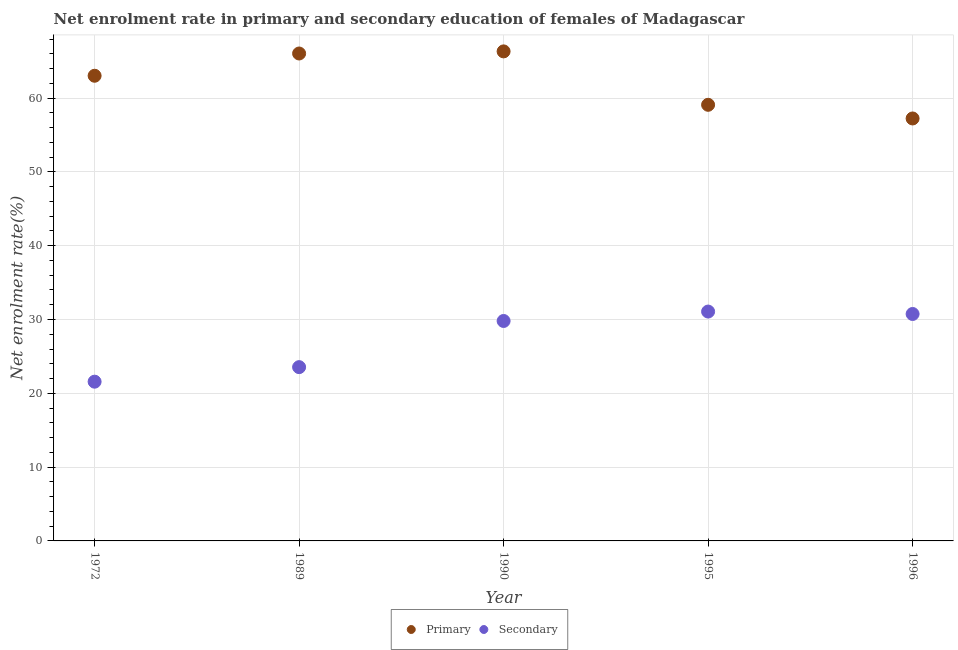Is the number of dotlines equal to the number of legend labels?
Ensure brevity in your answer.  Yes. What is the enrollment rate in primary education in 1972?
Your response must be concise. 63.02. Across all years, what is the maximum enrollment rate in primary education?
Offer a very short reply. 66.32. Across all years, what is the minimum enrollment rate in secondary education?
Your answer should be compact. 21.57. In which year was the enrollment rate in secondary education maximum?
Offer a terse response. 1995. In which year was the enrollment rate in secondary education minimum?
Make the answer very short. 1972. What is the total enrollment rate in primary education in the graph?
Offer a very short reply. 311.71. What is the difference between the enrollment rate in secondary education in 1990 and that in 1996?
Your answer should be compact. -0.95. What is the difference between the enrollment rate in secondary education in 1989 and the enrollment rate in primary education in 1990?
Provide a short and direct response. -42.78. What is the average enrollment rate in primary education per year?
Offer a very short reply. 62.34. In the year 1990, what is the difference between the enrollment rate in secondary education and enrollment rate in primary education?
Ensure brevity in your answer.  -36.52. What is the ratio of the enrollment rate in primary education in 1990 to that in 1996?
Provide a succinct answer. 1.16. Is the enrollment rate in secondary education in 1990 less than that in 1995?
Offer a terse response. Yes. What is the difference between the highest and the second highest enrollment rate in primary education?
Ensure brevity in your answer.  0.29. What is the difference between the highest and the lowest enrollment rate in primary education?
Offer a very short reply. 9.09. In how many years, is the enrollment rate in primary education greater than the average enrollment rate in primary education taken over all years?
Your response must be concise. 3. Does the enrollment rate in primary education monotonically increase over the years?
Provide a short and direct response. No. Is the enrollment rate in primary education strictly greater than the enrollment rate in secondary education over the years?
Your answer should be very brief. Yes. Is the enrollment rate in secondary education strictly less than the enrollment rate in primary education over the years?
Make the answer very short. Yes. How many dotlines are there?
Make the answer very short. 2. How many years are there in the graph?
Offer a terse response. 5. Does the graph contain grids?
Provide a short and direct response. Yes. Where does the legend appear in the graph?
Keep it short and to the point. Bottom center. How are the legend labels stacked?
Provide a short and direct response. Horizontal. What is the title of the graph?
Give a very brief answer. Net enrolment rate in primary and secondary education of females of Madagascar. Does "Working capital" appear as one of the legend labels in the graph?
Provide a succinct answer. No. What is the label or title of the X-axis?
Provide a succinct answer. Year. What is the label or title of the Y-axis?
Offer a terse response. Net enrolment rate(%). What is the Net enrolment rate(%) in Primary in 1972?
Ensure brevity in your answer.  63.02. What is the Net enrolment rate(%) of Secondary in 1972?
Ensure brevity in your answer.  21.57. What is the Net enrolment rate(%) in Primary in 1989?
Give a very brief answer. 66.04. What is the Net enrolment rate(%) in Secondary in 1989?
Your answer should be very brief. 23.55. What is the Net enrolment rate(%) of Primary in 1990?
Offer a terse response. 66.32. What is the Net enrolment rate(%) in Secondary in 1990?
Make the answer very short. 29.8. What is the Net enrolment rate(%) of Primary in 1995?
Provide a short and direct response. 59.09. What is the Net enrolment rate(%) in Secondary in 1995?
Ensure brevity in your answer.  31.08. What is the Net enrolment rate(%) in Primary in 1996?
Provide a short and direct response. 57.24. What is the Net enrolment rate(%) in Secondary in 1996?
Make the answer very short. 30.75. Across all years, what is the maximum Net enrolment rate(%) in Primary?
Keep it short and to the point. 66.32. Across all years, what is the maximum Net enrolment rate(%) of Secondary?
Make the answer very short. 31.08. Across all years, what is the minimum Net enrolment rate(%) of Primary?
Your answer should be very brief. 57.24. Across all years, what is the minimum Net enrolment rate(%) of Secondary?
Make the answer very short. 21.57. What is the total Net enrolment rate(%) in Primary in the graph?
Your answer should be very brief. 311.71. What is the total Net enrolment rate(%) in Secondary in the graph?
Provide a short and direct response. 136.74. What is the difference between the Net enrolment rate(%) in Primary in 1972 and that in 1989?
Ensure brevity in your answer.  -3.02. What is the difference between the Net enrolment rate(%) of Secondary in 1972 and that in 1989?
Provide a short and direct response. -1.97. What is the difference between the Net enrolment rate(%) of Primary in 1972 and that in 1990?
Offer a very short reply. -3.3. What is the difference between the Net enrolment rate(%) of Secondary in 1972 and that in 1990?
Keep it short and to the point. -8.22. What is the difference between the Net enrolment rate(%) in Primary in 1972 and that in 1995?
Keep it short and to the point. 3.94. What is the difference between the Net enrolment rate(%) of Secondary in 1972 and that in 1995?
Keep it short and to the point. -9.5. What is the difference between the Net enrolment rate(%) of Primary in 1972 and that in 1996?
Offer a very short reply. 5.79. What is the difference between the Net enrolment rate(%) in Secondary in 1972 and that in 1996?
Your response must be concise. -9.17. What is the difference between the Net enrolment rate(%) of Primary in 1989 and that in 1990?
Provide a succinct answer. -0.29. What is the difference between the Net enrolment rate(%) in Secondary in 1989 and that in 1990?
Make the answer very short. -6.25. What is the difference between the Net enrolment rate(%) of Primary in 1989 and that in 1995?
Ensure brevity in your answer.  6.95. What is the difference between the Net enrolment rate(%) in Secondary in 1989 and that in 1995?
Ensure brevity in your answer.  -7.53. What is the difference between the Net enrolment rate(%) in Primary in 1989 and that in 1996?
Keep it short and to the point. 8.8. What is the difference between the Net enrolment rate(%) of Secondary in 1989 and that in 1996?
Keep it short and to the point. -7.2. What is the difference between the Net enrolment rate(%) in Primary in 1990 and that in 1995?
Your response must be concise. 7.24. What is the difference between the Net enrolment rate(%) in Secondary in 1990 and that in 1995?
Offer a very short reply. -1.28. What is the difference between the Net enrolment rate(%) of Primary in 1990 and that in 1996?
Your response must be concise. 9.09. What is the difference between the Net enrolment rate(%) of Secondary in 1990 and that in 1996?
Offer a terse response. -0.95. What is the difference between the Net enrolment rate(%) in Primary in 1995 and that in 1996?
Your answer should be very brief. 1.85. What is the difference between the Net enrolment rate(%) of Secondary in 1995 and that in 1996?
Offer a terse response. 0.33. What is the difference between the Net enrolment rate(%) in Primary in 1972 and the Net enrolment rate(%) in Secondary in 1989?
Your response must be concise. 39.48. What is the difference between the Net enrolment rate(%) of Primary in 1972 and the Net enrolment rate(%) of Secondary in 1990?
Your response must be concise. 33.22. What is the difference between the Net enrolment rate(%) in Primary in 1972 and the Net enrolment rate(%) in Secondary in 1995?
Your response must be concise. 31.95. What is the difference between the Net enrolment rate(%) in Primary in 1972 and the Net enrolment rate(%) in Secondary in 1996?
Offer a very short reply. 32.28. What is the difference between the Net enrolment rate(%) in Primary in 1989 and the Net enrolment rate(%) in Secondary in 1990?
Offer a terse response. 36.24. What is the difference between the Net enrolment rate(%) of Primary in 1989 and the Net enrolment rate(%) of Secondary in 1995?
Offer a terse response. 34.96. What is the difference between the Net enrolment rate(%) in Primary in 1989 and the Net enrolment rate(%) in Secondary in 1996?
Offer a terse response. 35.29. What is the difference between the Net enrolment rate(%) in Primary in 1990 and the Net enrolment rate(%) in Secondary in 1995?
Your answer should be very brief. 35.25. What is the difference between the Net enrolment rate(%) of Primary in 1990 and the Net enrolment rate(%) of Secondary in 1996?
Keep it short and to the point. 35.58. What is the difference between the Net enrolment rate(%) of Primary in 1995 and the Net enrolment rate(%) of Secondary in 1996?
Make the answer very short. 28.34. What is the average Net enrolment rate(%) of Primary per year?
Provide a succinct answer. 62.34. What is the average Net enrolment rate(%) in Secondary per year?
Make the answer very short. 27.35. In the year 1972, what is the difference between the Net enrolment rate(%) in Primary and Net enrolment rate(%) in Secondary?
Provide a succinct answer. 41.45. In the year 1989, what is the difference between the Net enrolment rate(%) in Primary and Net enrolment rate(%) in Secondary?
Make the answer very short. 42.49. In the year 1990, what is the difference between the Net enrolment rate(%) in Primary and Net enrolment rate(%) in Secondary?
Give a very brief answer. 36.52. In the year 1995, what is the difference between the Net enrolment rate(%) of Primary and Net enrolment rate(%) of Secondary?
Make the answer very short. 28.01. In the year 1996, what is the difference between the Net enrolment rate(%) of Primary and Net enrolment rate(%) of Secondary?
Keep it short and to the point. 26.49. What is the ratio of the Net enrolment rate(%) in Primary in 1972 to that in 1989?
Your answer should be very brief. 0.95. What is the ratio of the Net enrolment rate(%) in Secondary in 1972 to that in 1989?
Give a very brief answer. 0.92. What is the ratio of the Net enrolment rate(%) in Primary in 1972 to that in 1990?
Ensure brevity in your answer.  0.95. What is the ratio of the Net enrolment rate(%) of Secondary in 1972 to that in 1990?
Your response must be concise. 0.72. What is the ratio of the Net enrolment rate(%) in Primary in 1972 to that in 1995?
Keep it short and to the point. 1.07. What is the ratio of the Net enrolment rate(%) in Secondary in 1972 to that in 1995?
Your answer should be compact. 0.69. What is the ratio of the Net enrolment rate(%) in Primary in 1972 to that in 1996?
Your response must be concise. 1.1. What is the ratio of the Net enrolment rate(%) of Secondary in 1972 to that in 1996?
Make the answer very short. 0.7. What is the ratio of the Net enrolment rate(%) in Secondary in 1989 to that in 1990?
Give a very brief answer. 0.79. What is the ratio of the Net enrolment rate(%) in Primary in 1989 to that in 1995?
Ensure brevity in your answer.  1.12. What is the ratio of the Net enrolment rate(%) in Secondary in 1989 to that in 1995?
Your response must be concise. 0.76. What is the ratio of the Net enrolment rate(%) of Primary in 1989 to that in 1996?
Keep it short and to the point. 1.15. What is the ratio of the Net enrolment rate(%) of Secondary in 1989 to that in 1996?
Your answer should be compact. 0.77. What is the ratio of the Net enrolment rate(%) in Primary in 1990 to that in 1995?
Make the answer very short. 1.12. What is the ratio of the Net enrolment rate(%) in Secondary in 1990 to that in 1995?
Offer a terse response. 0.96. What is the ratio of the Net enrolment rate(%) of Primary in 1990 to that in 1996?
Your response must be concise. 1.16. What is the ratio of the Net enrolment rate(%) of Secondary in 1990 to that in 1996?
Ensure brevity in your answer.  0.97. What is the ratio of the Net enrolment rate(%) in Primary in 1995 to that in 1996?
Provide a short and direct response. 1.03. What is the ratio of the Net enrolment rate(%) in Secondary in 1995 to that in 1996?
Offer a very short reply. 1.01. What is the difference between the highest and the second highest Net enrolment rate(%) of Primary?
Make the answer very short. 0.29. What is the difference between the highest and the second highest Net enrolment rate(%) in Secondary?
Keep it short and to the point. 0.33. What is the difference between the highest and the lowest Net enrolment rate(%) in Primary?
Give a very brief answer. 9.09. What is the difference between the highest and the lowest Net enrolment rate(%) of Secondary?
Your response must be concise. 9.5. 